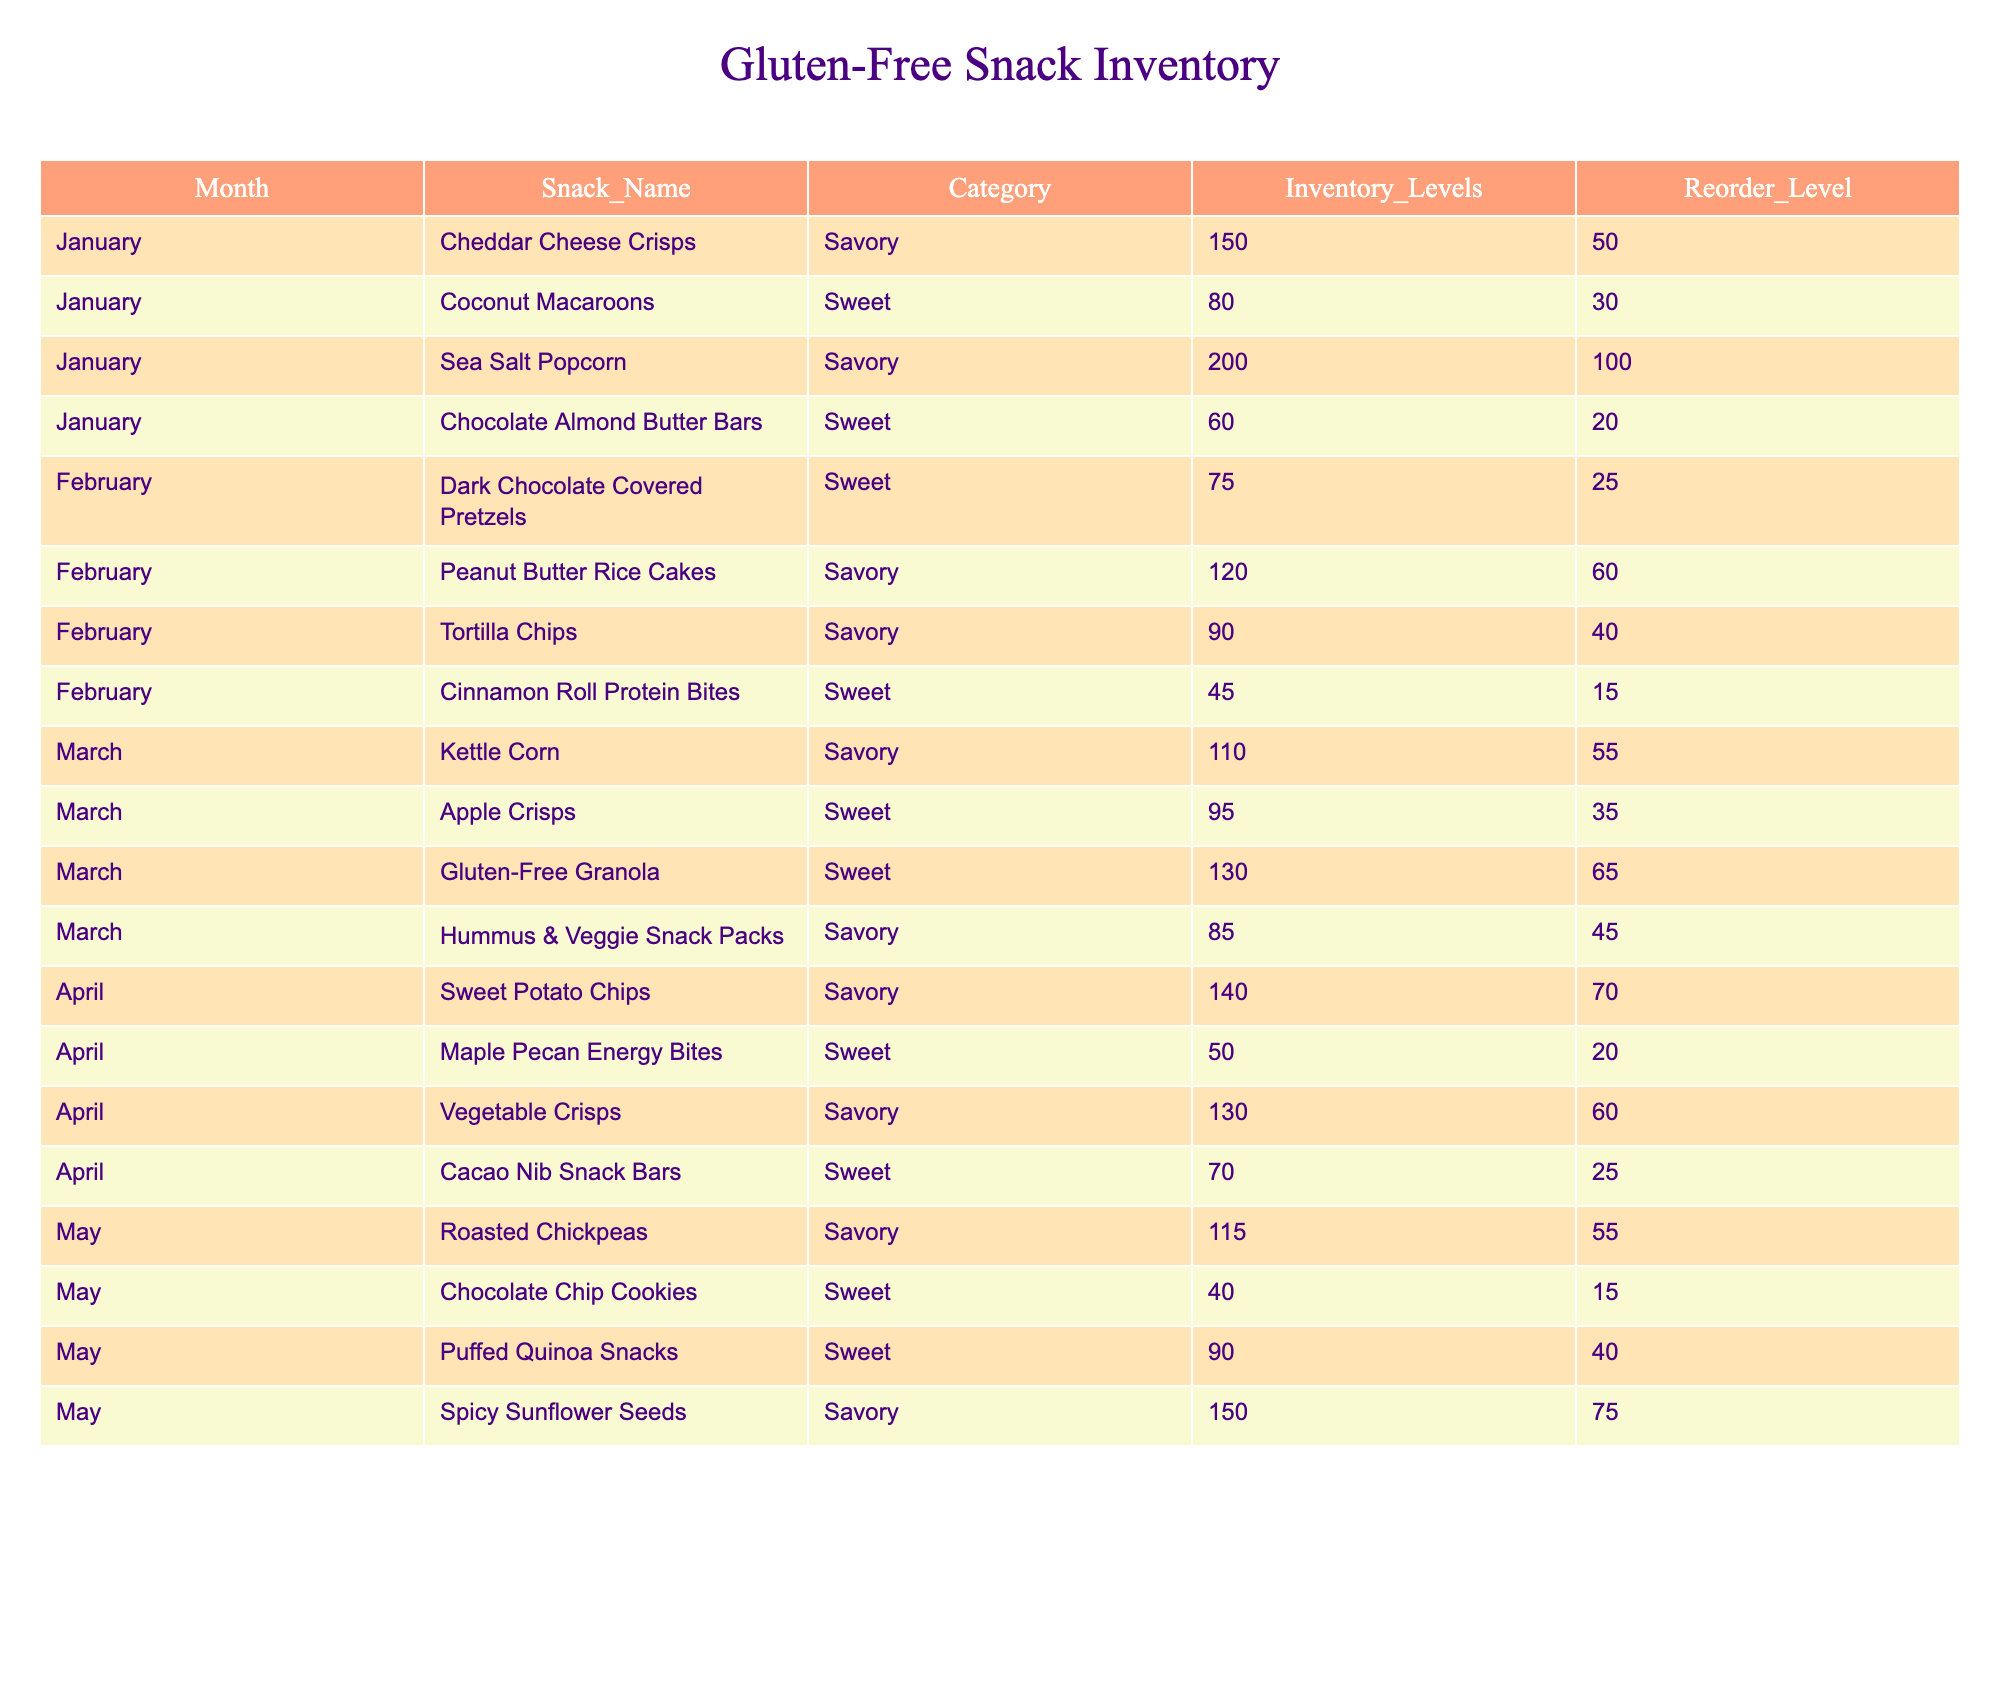What snacks had an inventory level of 150 in January? In January, the inventory levels for Cheddar Cheese Crisps and Sea Salt Popcorn are both at 150. We can refer to the respective rows in the table to find this information.
Answer: Cheddar Cheese Crisps, Sea Salt Popcorn How many total sweet snacks were listed in February? The sweet snacks listed in February are Dark Chocolate Covered Pretzels, Cinnamon Roll Protein Bites, and the Maple Pecan Energy Bites. The count of sweet snacks in February totals to three.
Answer: 3 What is the average inventory level of savory snacks in March? The savory snacks in March are Kettle Corn (110), Hummus & Veggie Snack Packs (85), and the average is calculated as (110 + 85) / 2 = 97.5. After rounding, it's approximately 98.
Answer: 98 Did the inventory levels of Peanut Butter Rice Cakes exceed their reorder level in February? Peanut Butter Rice Cakes had an inventory level of 120, which is greater than the reorder level of 60. Comparing these two values confirms the fact.
Answer: Yes Which sweet snack had the lowest inventory in May? The snacks listed in May include Chocolate Chip Cookies (40), Puffed Quinoa Snacks (90), and the lowest inventory is found to be 40. Evaluating all sweet snacks shows that Chocolate Chip Cookies have the lowest inventory.
Answer: Chocolate Chip Cookies What is the total inventory level of savory snacks across all months? The savory snacks across all months can be found by summing their inventory levels: January (150 + 200), February (120 + 90), March (110 + 85), April (140 + 130), May (115 + 150). Adding these gives (350 + 210 + 195 + 270 + 265) = 1290.
Answer: 1290 Which month had the highest inventory level among sweet snacks? Reviewing the sweet snacks for each month: January (80 + 60 = 140), February (75 + 45 = 120), March (95 + 130 = 225), April (50 + 70 = 120), and May (40). March has the highest total at 225.
Answer: March Are there any savory snacks with inventory levels below their reorder levels in the entire table? From the table, the only savory snack with inventory below its reorder level is the Hummus & Veggie Snack Packs in March at an inventory of 85 versus a reorder level of 45, so the answer is no.
Answer: No 